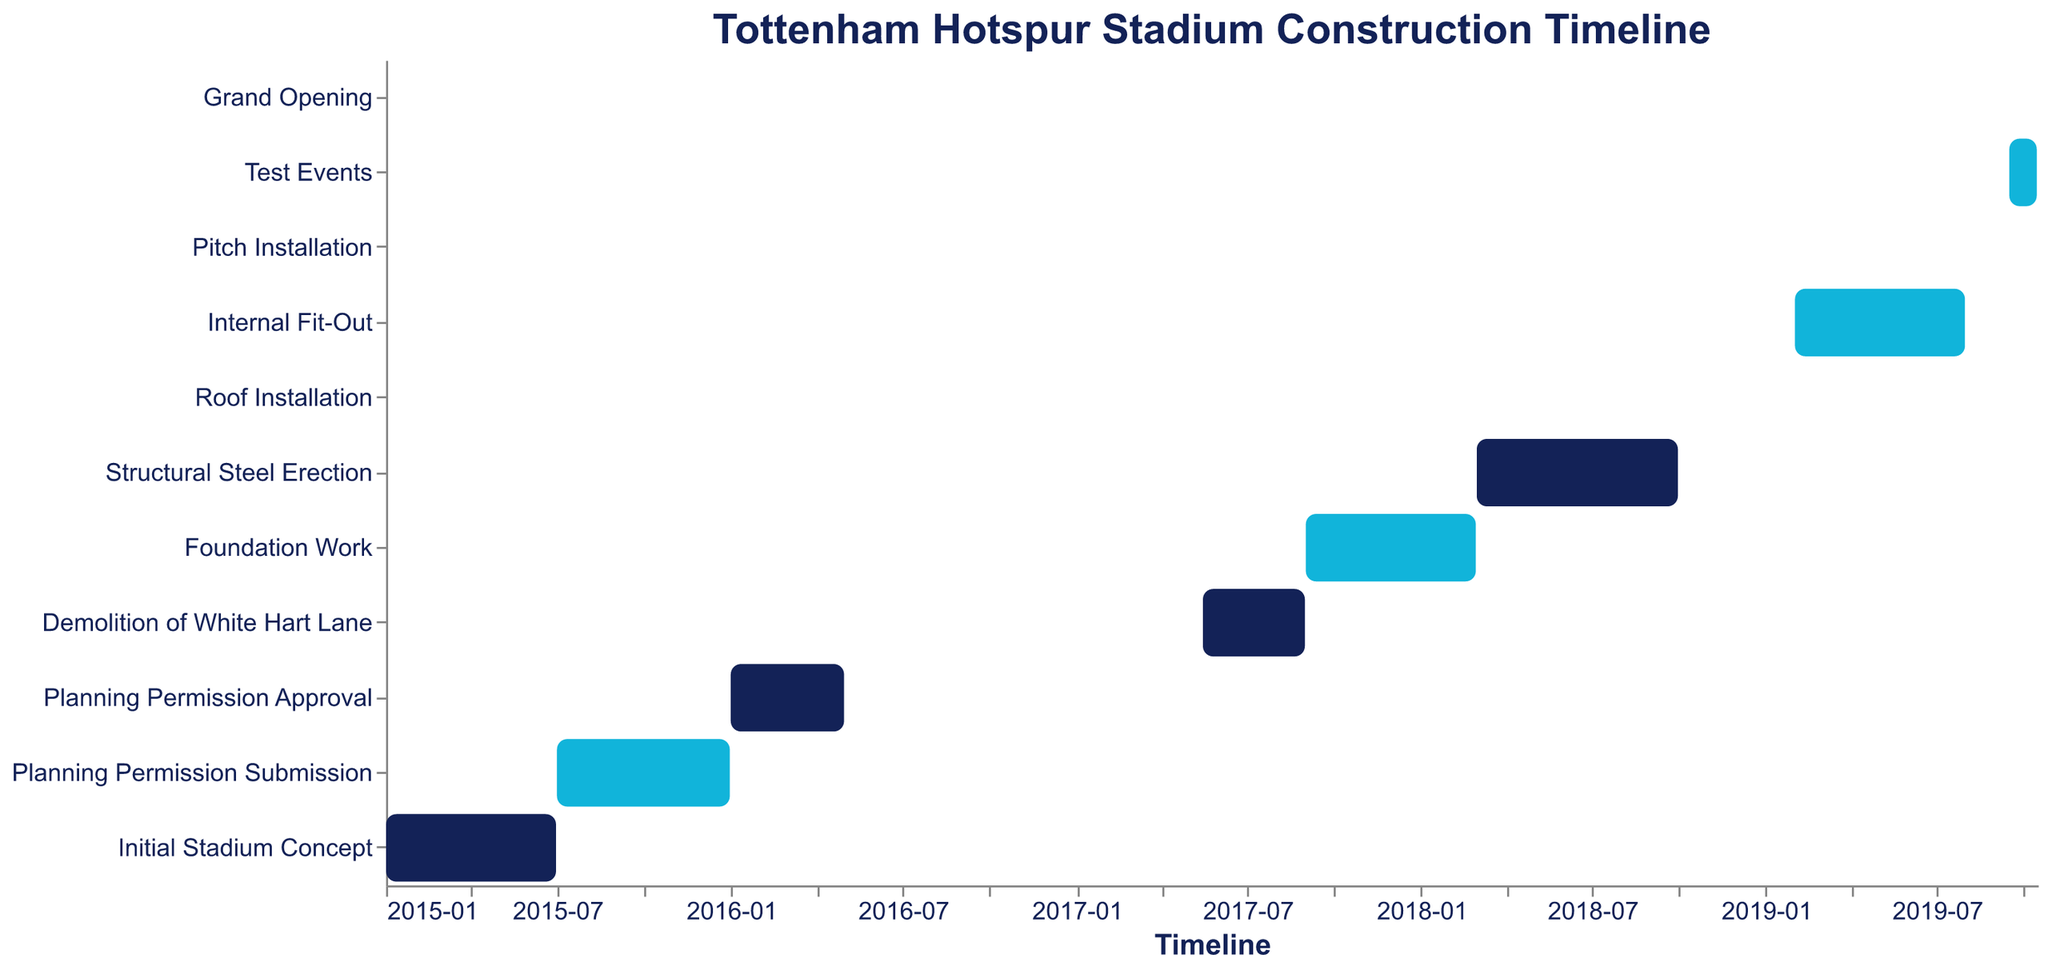What's the title of the figure? The title can be found at the top of the figure, and it reads "Tottenham Hotspur Stadium Construction Timeline".
Answer: Tottenham Hotspur Stadium Construction Timeline What task directly follows 'Initial Stadium Concept'? To answer this, look for the task that starts immediately after 'Initial Stadium Concept' ends on the timeline. The next task, according to the timeline, is 'Planning Permission Submission'.
Answer: Planning Permission Submission When did the 'Roof Installation' start and end? The start and end dates for 'Roof Installation' can be seen on the timeline bar for this task. It started on 2018-10-01 and ended on 2019-01-31.
Answer: Started: 2018-10-01, Ended: 2019-01-31 Which task has the shortest duration? To identify the task with the shortest duration, we need to compare the length of time between the start and end dates of each task visually. 'Grand Opening' is the shortest, as it only spans a single day on 2019-10-16.
Answer: Grand Opening How long did 'Foundation Work' take to complete? Calculate the duration between the start date (2017-09-01) and the end date (2018-02-28). The total duration includes the months of September 2017 to February 2018, which is 6 months.
Answer: 6 months Which tasks were active during the year 2018? To find this, check the timeline for tasks that overlap with any part of 2018. The tasks are 'Foundation Work', 'Structural Steel Erection', 'Roof Installation'.
Answer: Foundation Work, Structural Steel Erection, Roof Installation What is the combined duration of 'Demolition of White Hart Lane' and 'Foundation Work'? First, note the duration of 'Demolition of White Hart Lane' (May 15, 2017 - Aug 31, 2017) which is 3.5 months, and then 'Foundation Work' (Sep 01, 2017 - Feb 28, 2018) which is 6 months. Adding these gives 3.5 + 6 = 9.5 months.
Answer: 9.5 months Which task took the longest time to complete? Visually inspect the lengths of all the bars to identify the longest one. 'Structural Steel Erection' has the longest duration from 2018-03-01 to 2018-09-30, which is 7 months.
Answer: Structural Steel Erection How many tasks were completed before 2018? Look for tasks that have an end date before 2018. 'Initial Stadium Concept', 'Planning Permission Submission', 'Planning Permission Approval', and 'Demolition of White Hart Lane' are the tasks completed before 2018. This gives 4 tasks in total.
Answer: 4 tasks Which tasks overlap with 'Internal Fit-Out'? 'Internal Fit-Out' runs from Feb 01, 2019 to Jul 31, 2019. Therefore, the overlapping tasks are 'Roof Installation' (until Jan 31, 2019) and 'Pitch Installation' (Aug 01, 2019 - Sep 15, 2019), which do not overlap. Only 'Internal Fit-Out' itself is active in this period without any overlap.
Answer: Internal Fit-Out only 